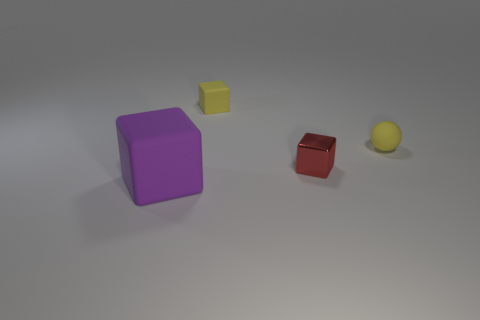Is there any other thing that has the same size as the purple block?
Provide a short and direct response. No. Are any red balls visible?
Ensure brevity in your answer.  No. What size is the rubber cube that is in front of the matte ball?
Your answer should be very brief. Large. How many cubes are the same color as the small ball?
Offer a very short reply. 1. How many cylinders are shiny objects or yellow things?
Offer a terse response. 0. The thing that is behind the large matte block and on the left side of the small metal object has what shape?
Provide a short and direct response. Cube. Is there a sphere that has the same size as the yellow matte block?
Provide a short and direct response. Yes. How many objects are matte objects behind the tiny metal thing or red metal spheres?
Your answer should be very brief. 2. Is the small red cube made of the same material as the small object to the right of the red object?
Your answer should be compact. No. What number of objects are small blocks behind the small shiny thing or tiny yellow things right of the small yellow block?
Your answer should be very brief. 2. 